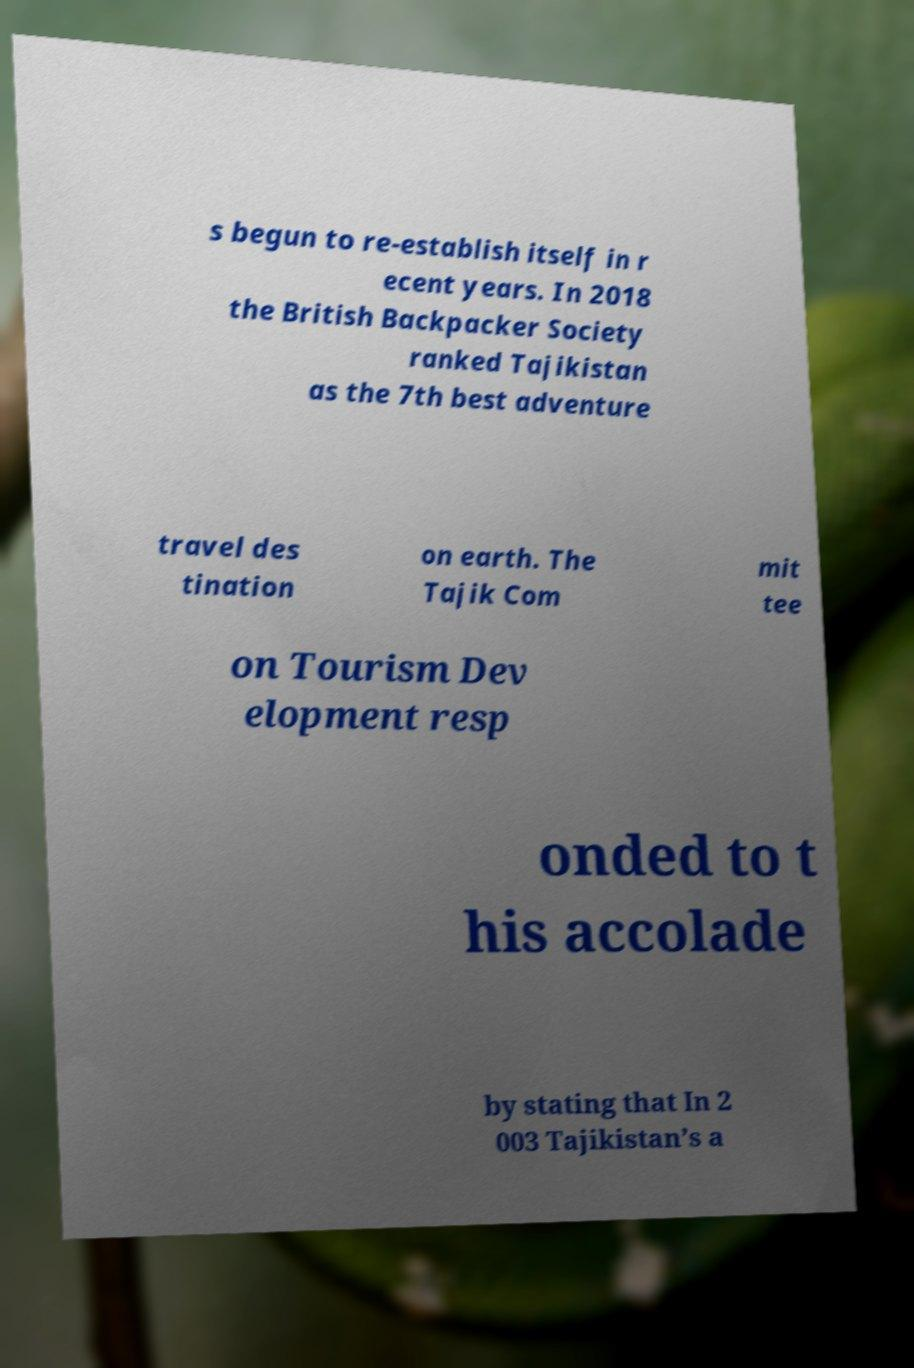Could you assist in decoding the text presented in this image and type it out clearly? s begun to re-establish itself in r ecent years. In 2018 the British Backpacker Society ranked Tajikistan as the 7th best adventure travel des tination on earth. The Tajik Com mit tee on Tourism Dev elopment resp onded to t his accolade by stating that In 2 003 Tajikistan’s a 